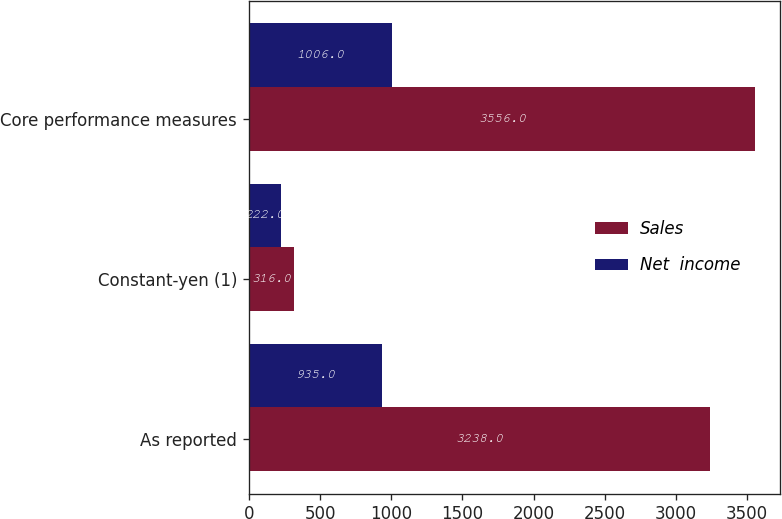<chart> <loc_0><loc_0><loc_500><loc_500><stacked_bar_chart><ecel><fcel>As reported<fcel>Constant-yen (1)<fcel>Core performance measures<nl><fcel>Sales<fcel>3238<fcel>316<fcel>3556<nl><fcel>Net  income<fcel>935<fcel>222<fcel>1006<nl></chart> 